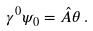Convert formula to latex. <formula><loc_0><loc_0><loc_500><loc_500>\gamma ^ { 0 } \psi _ { 0 } = \hat { A } \theta \, .</formula> 